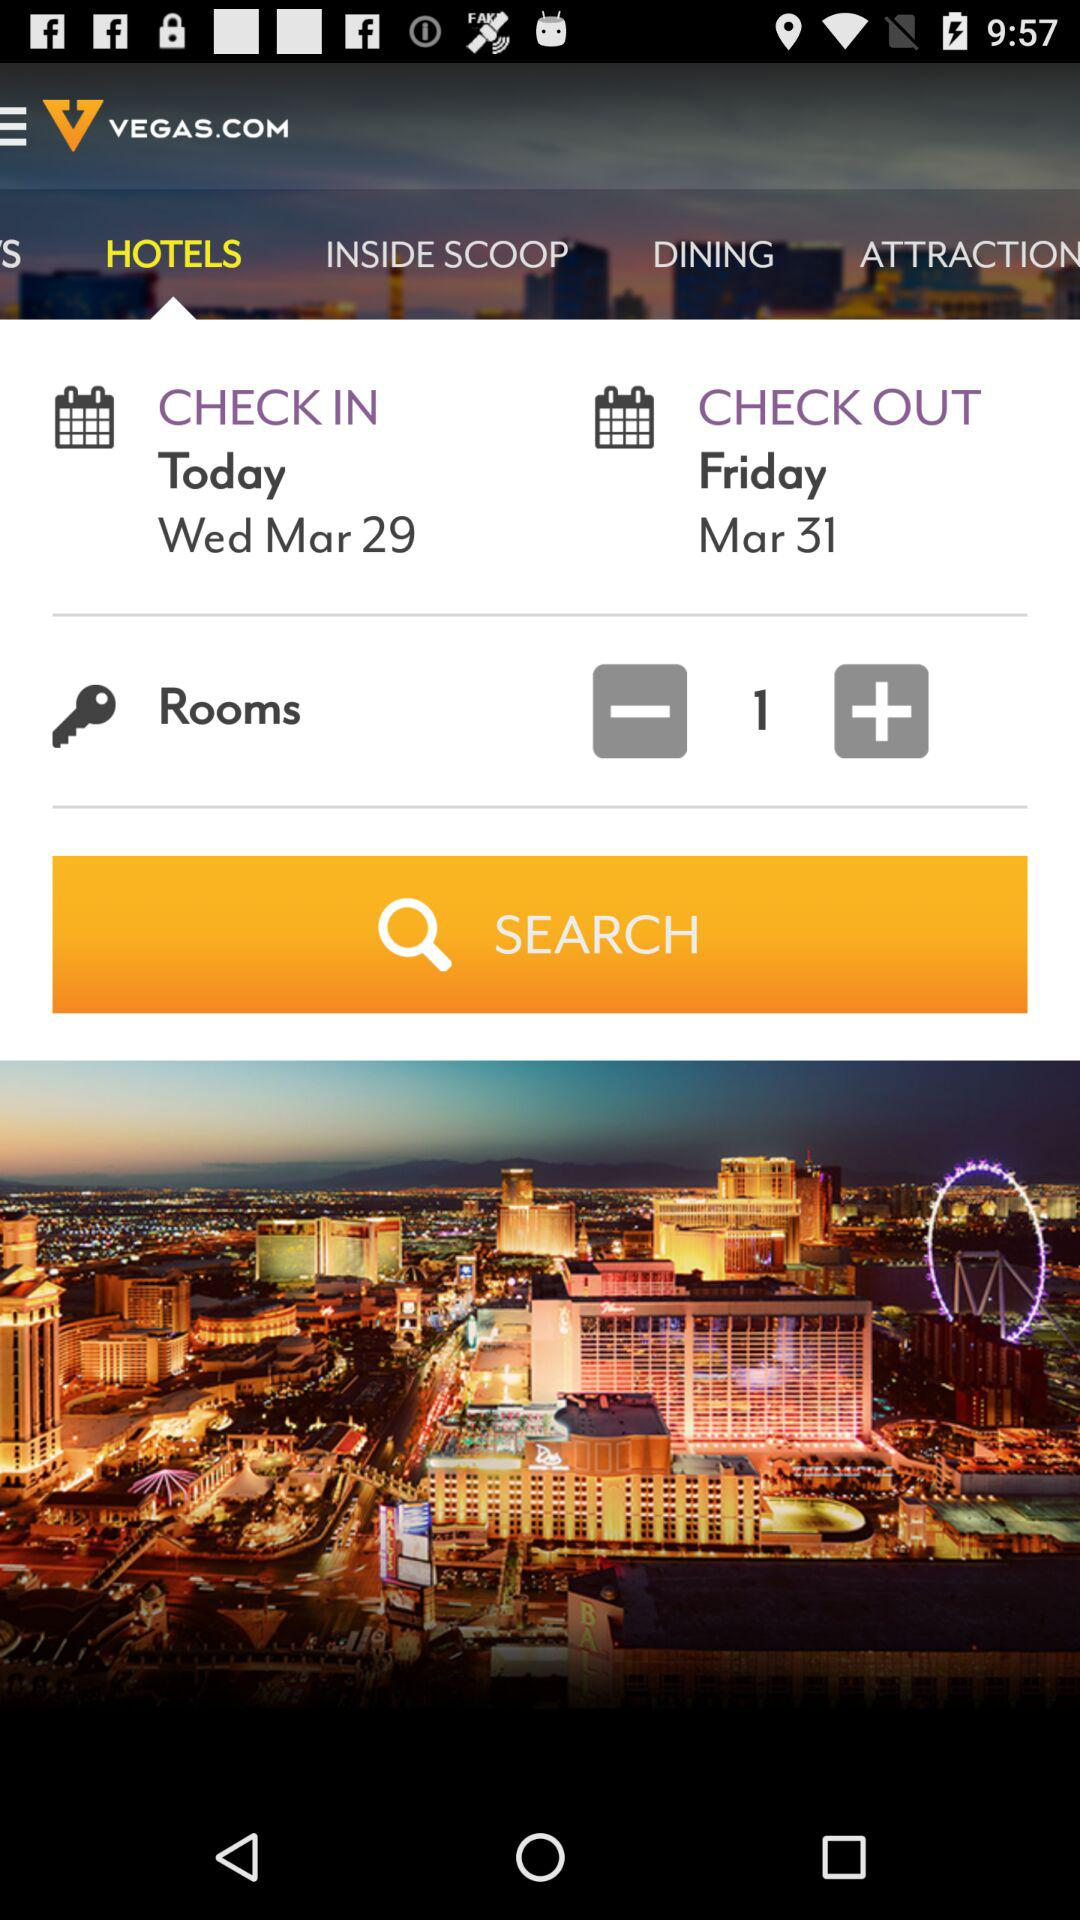How many rooms are selected? There is 1 room selected. 